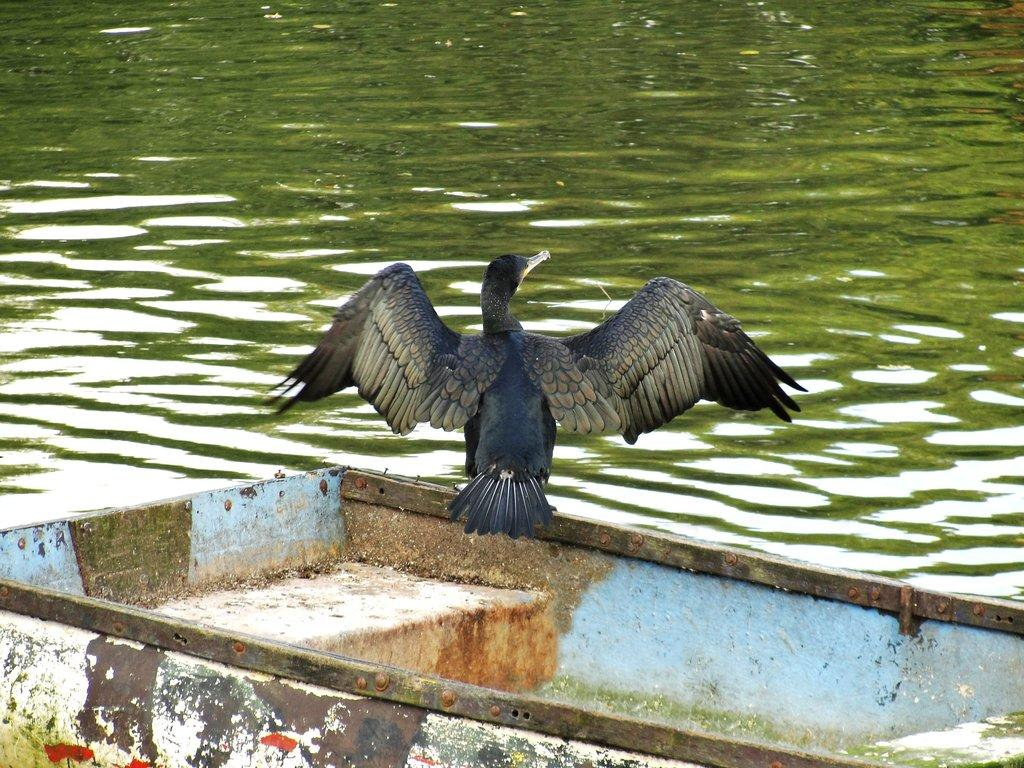What type of animal can be seen in the image? There is a bird in the image. What is the bird doing in the image? The bird is standing on a surface. What can be seen in the background of the image? There is water visible in the background of the image. What type of guide is the bird holding in the image? There is no guide present in the image; it is a bird standing on a surface with water visible in the background. 